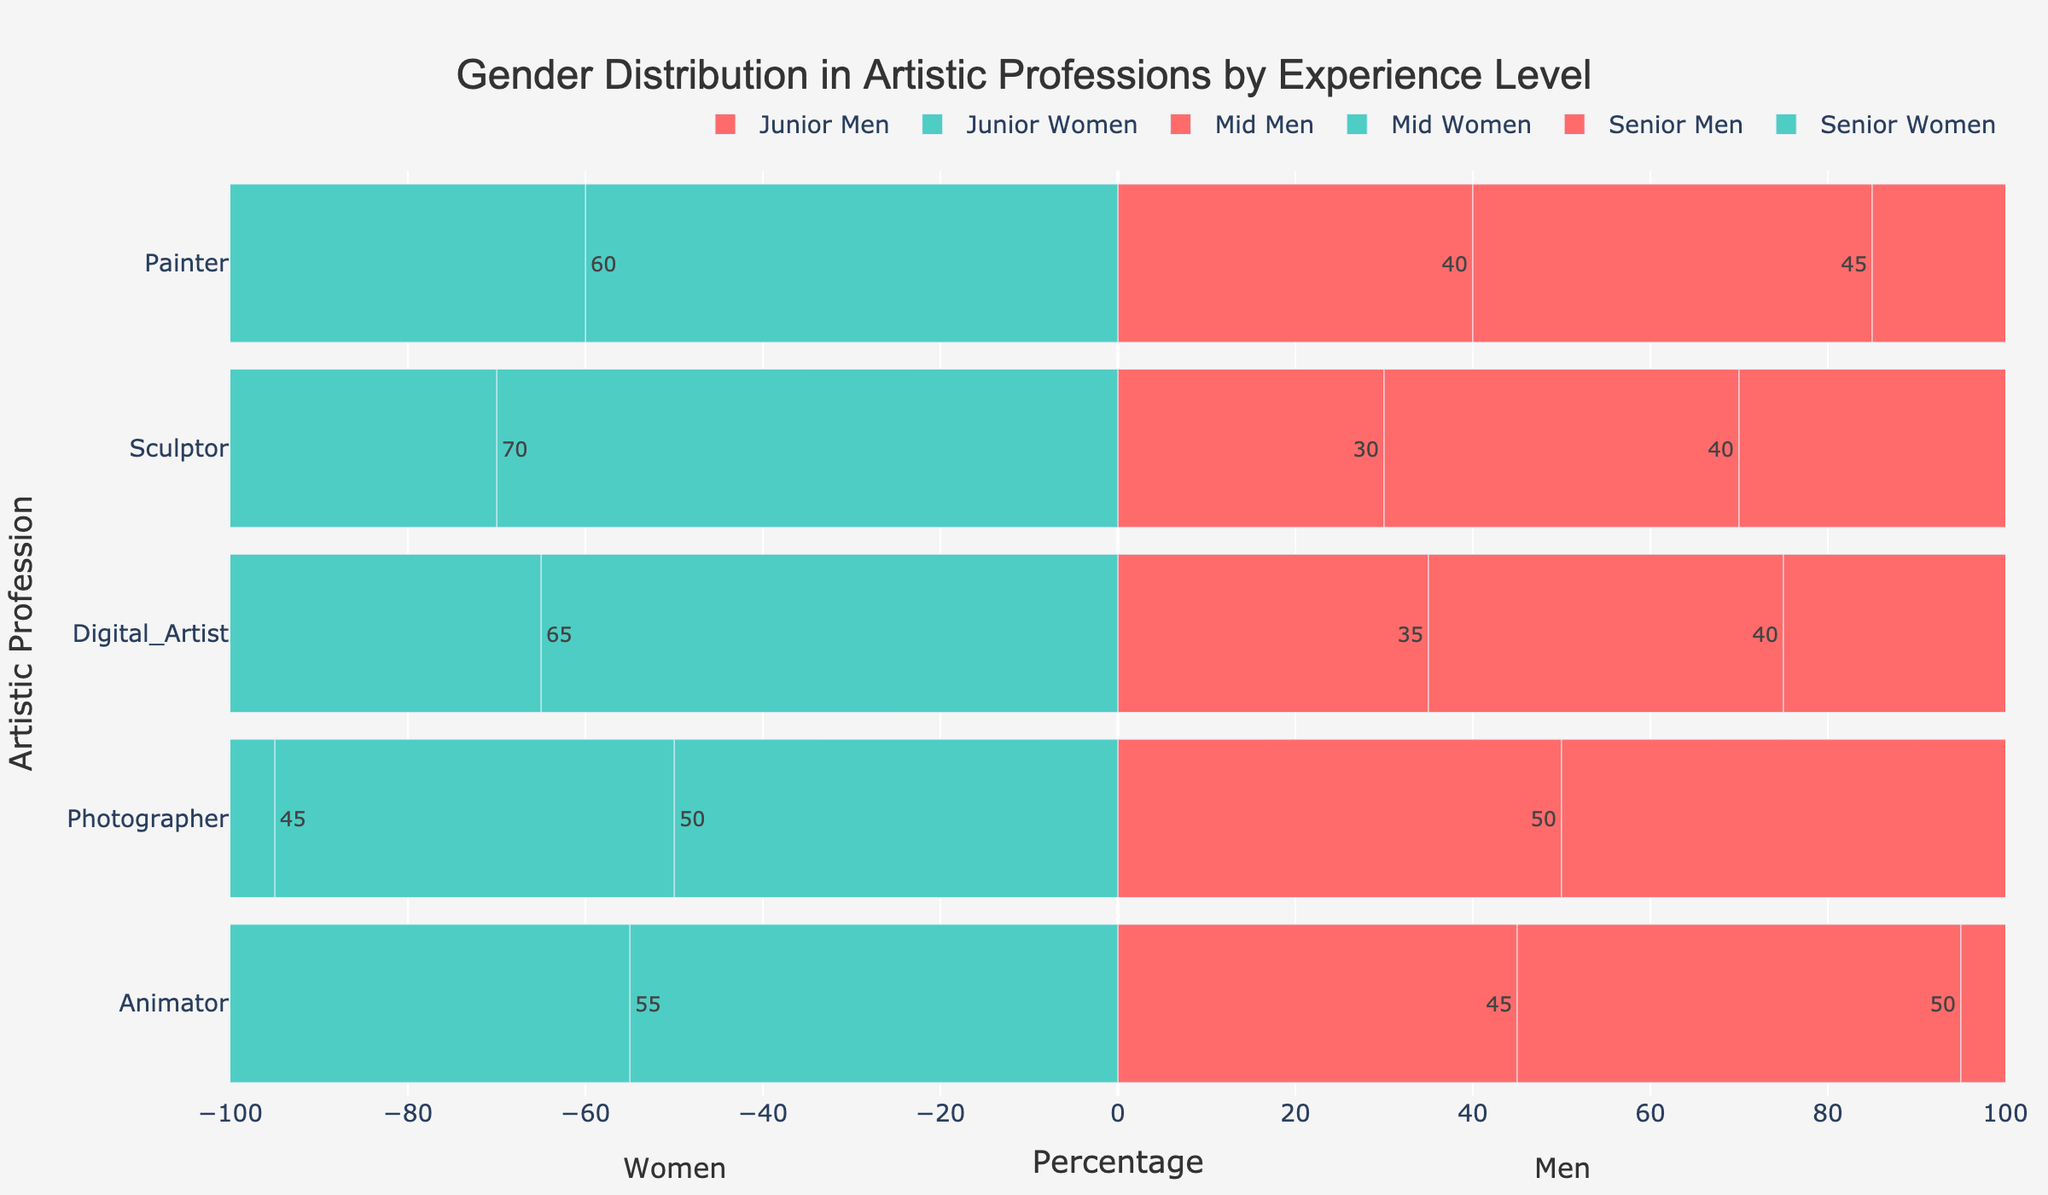What profession has the highest percentage of women at the junior level? Look at the bars representing women at the junior level and find the tallest. For Sculptors, the percentage is 70%, which is the highest.
Answer: Sculptor Which artistic profession has the most balanced gender distribution at the senior level? Check the bars for the senior level and find the profession where men's and women's percentages are equal. For Painters, both men and women have a 50% share.
Answer: Painter Compare the percentage of junior men and senior women for Digital Artists. Which group has a higher percentage? Locate the junior men and senior women for Digital Artists. Junior men have 35%, and senior women have 55%.
Answer: Senior women What is the total percentage of men in the three experience levels combined for Photographers? Add the percentages of men in all experience levels for Photographers: 50% (Junior) + 55% (Mid) + 60% (Senior) = 165%.
Answer: 165% Which profession has a higher percentage of men at the mid level, Painters or Digital Artists? Compare the bars for mid-level men in both professions. Painters show 45%, and Digital Artists show 40%.
Answer: Painters How many artistic professions have a higher percentage of senior men than senior women? Count the professions where the senior men's bar is longer than the senior women's bar. For Sculptors, Photographers, and Animators, men have a higher percentage.
Answer: Three By what percentage is the senior men's share higher than the junior men's share for Animators? Subtract the junior men's percentage from the senior men's percentage for Animators: 55% (Senior) - 45% (Junior) = 10%.
Answer: 10% What is the average percentage of women across all experience levels for Sculptors? Sum the percentages of women in all levels for Sculptors and divide by 3: (70% + 60% + 45%) / 3 = 58.33%.
Answer: 58.33% Which profession has the least difference between men and women at the mid level? Determine the difference for each profession's mid level and find the smallest. For Animators, the difference is 0% (50% men - 50% women).
Answer: Animator Are there any experience levels where women have a higher percentage of representation across all professions? Check each experience level's bars for all professions. For Juniors, women have higher percentages than men in every profession.
Answer: Junior 